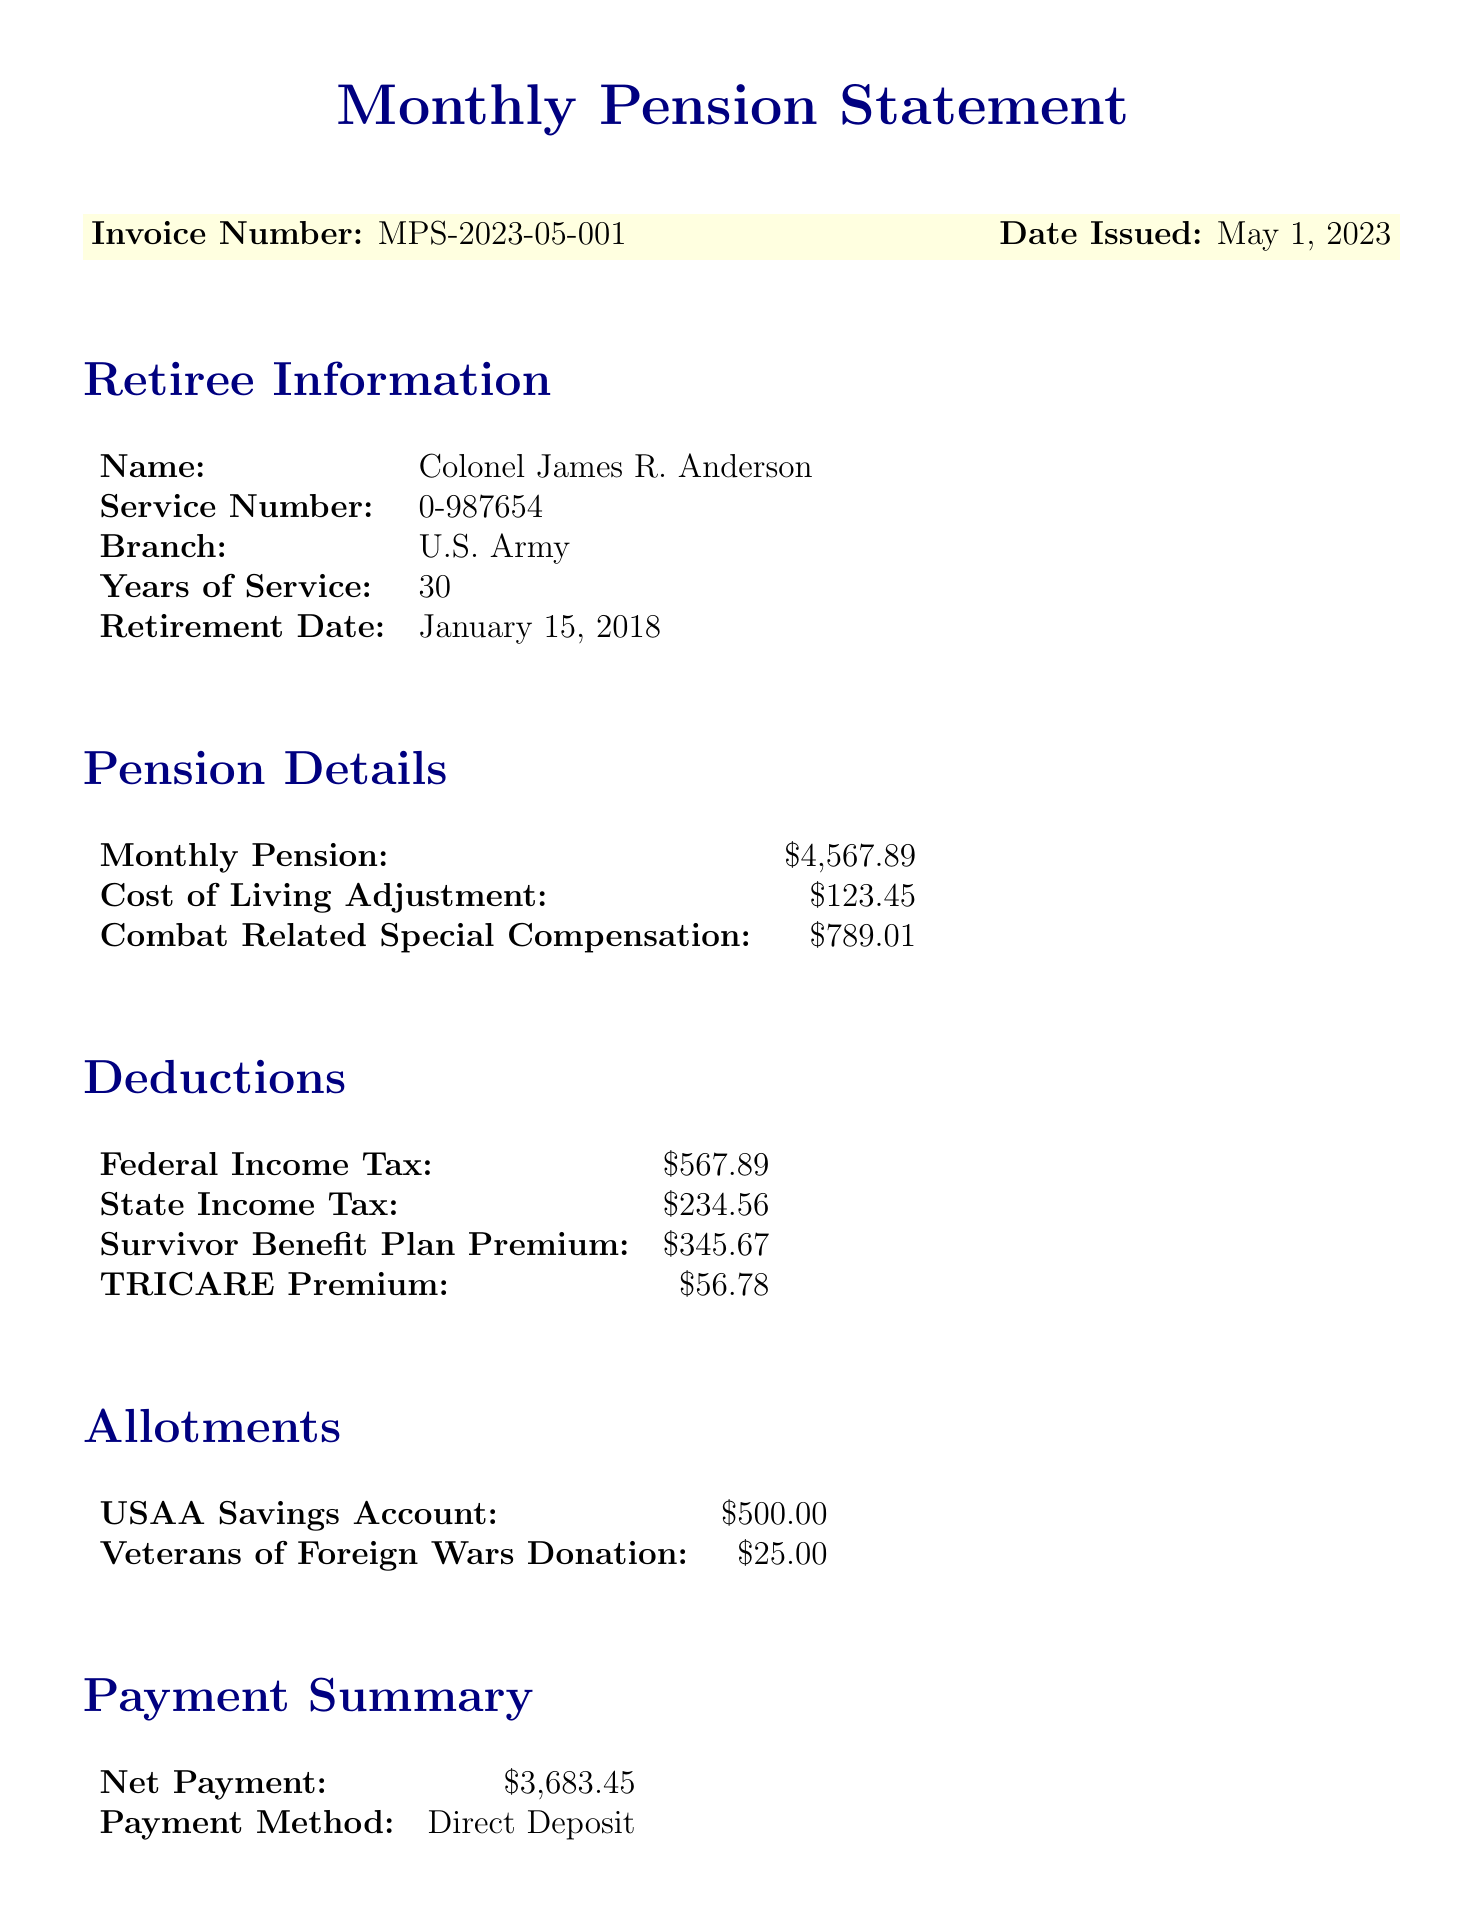What is the invoice number? The invoice number is listed at the top of the document for identification purposes.
Answer: MPS-2023-05-001 What is the amount of the monthly pension? The monthly pension amount is specified in the Pension Details section of the document.
Answer: $4,567.89 What is the total amount deducted for federal income tax? The deductions include various tax amounts, and the federal income tax deduction is specifically mentioned.
Answer: $567.89 What is the net payment amount? The net payment is the final amount after deductions and allotments are accounted for, found in the Payment Summary section.
Answer: $3,683.45 Who is the retiree? The retiree's name is a key piece of information presented prominently in the Retiree Information section.
Answer: Colonel James R. Anderson What is the total number of retirement points? The retirement points summary shows the total number of points earned throughout the service.
Answer: 7,890 How much is the TRICARE premium? The TRICARE premium amount is listed among the deductions, indicating costs for health coverage.
Answer: $56.78 When is the next statement date? The next statement date informs the retiree when to expect the following pension statement.
Answer: June 1, 2023 What organization is listed for donations? The allotments section specifies organizations to which the retiree has chosen to donate, reflecting personal contributions.
Answer: Veterans of Foreign Wars 